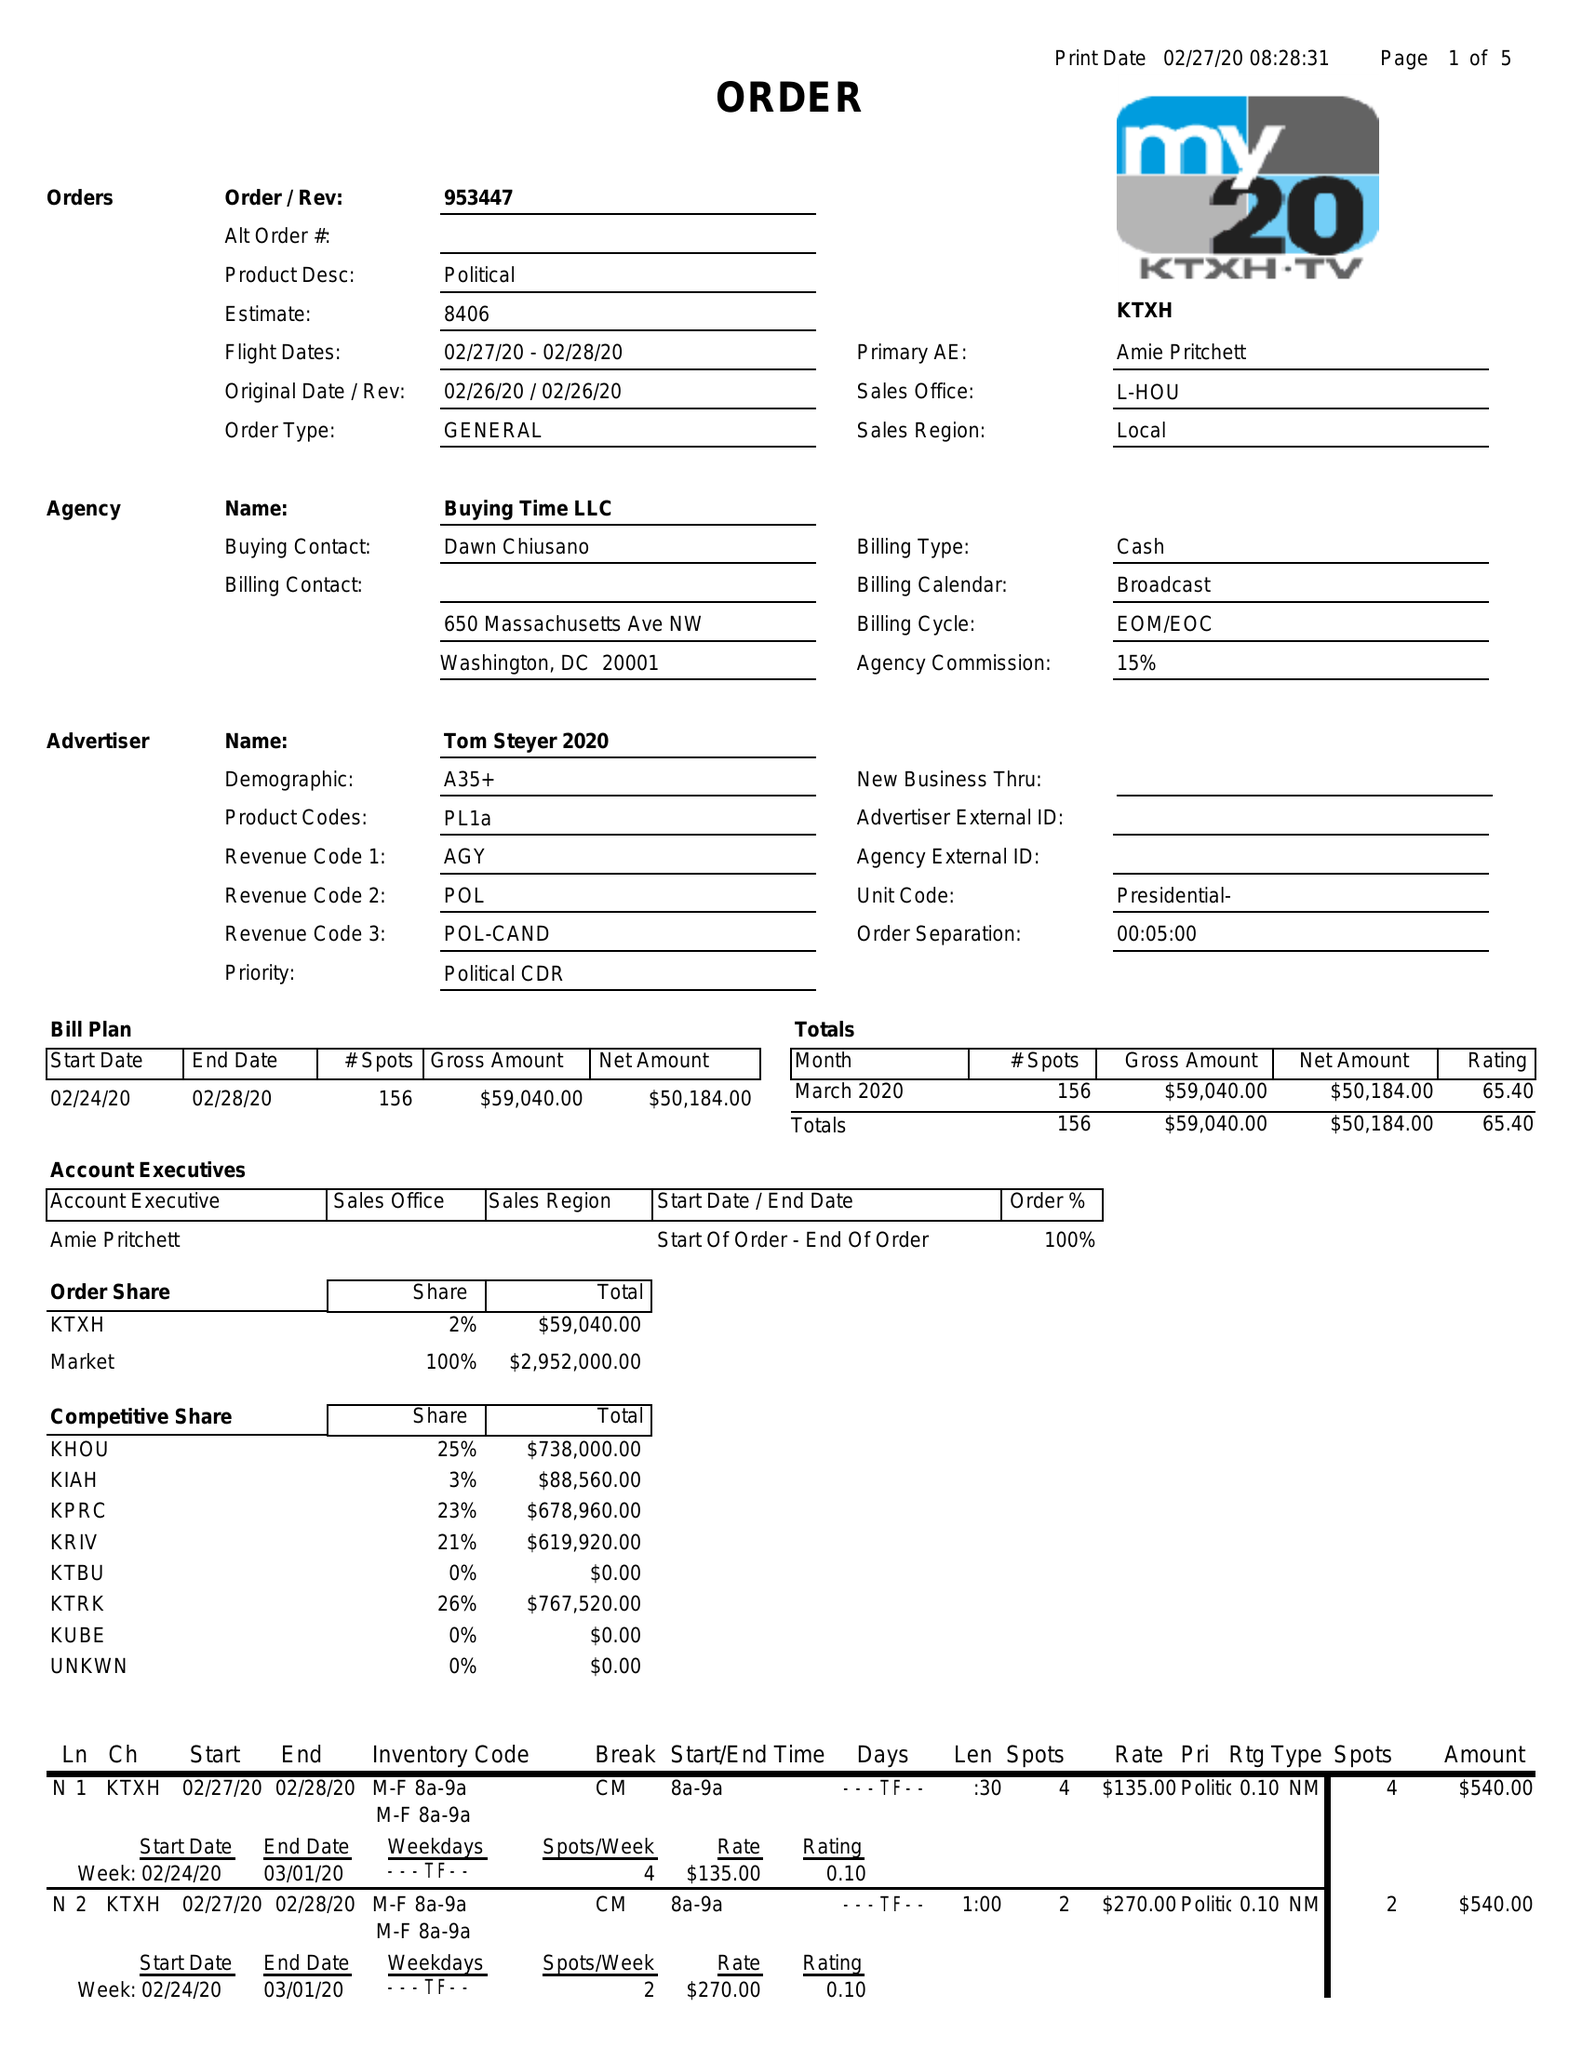What is the value for the flight_to?
Answer the question using a single word or phrase. 02/28/20 